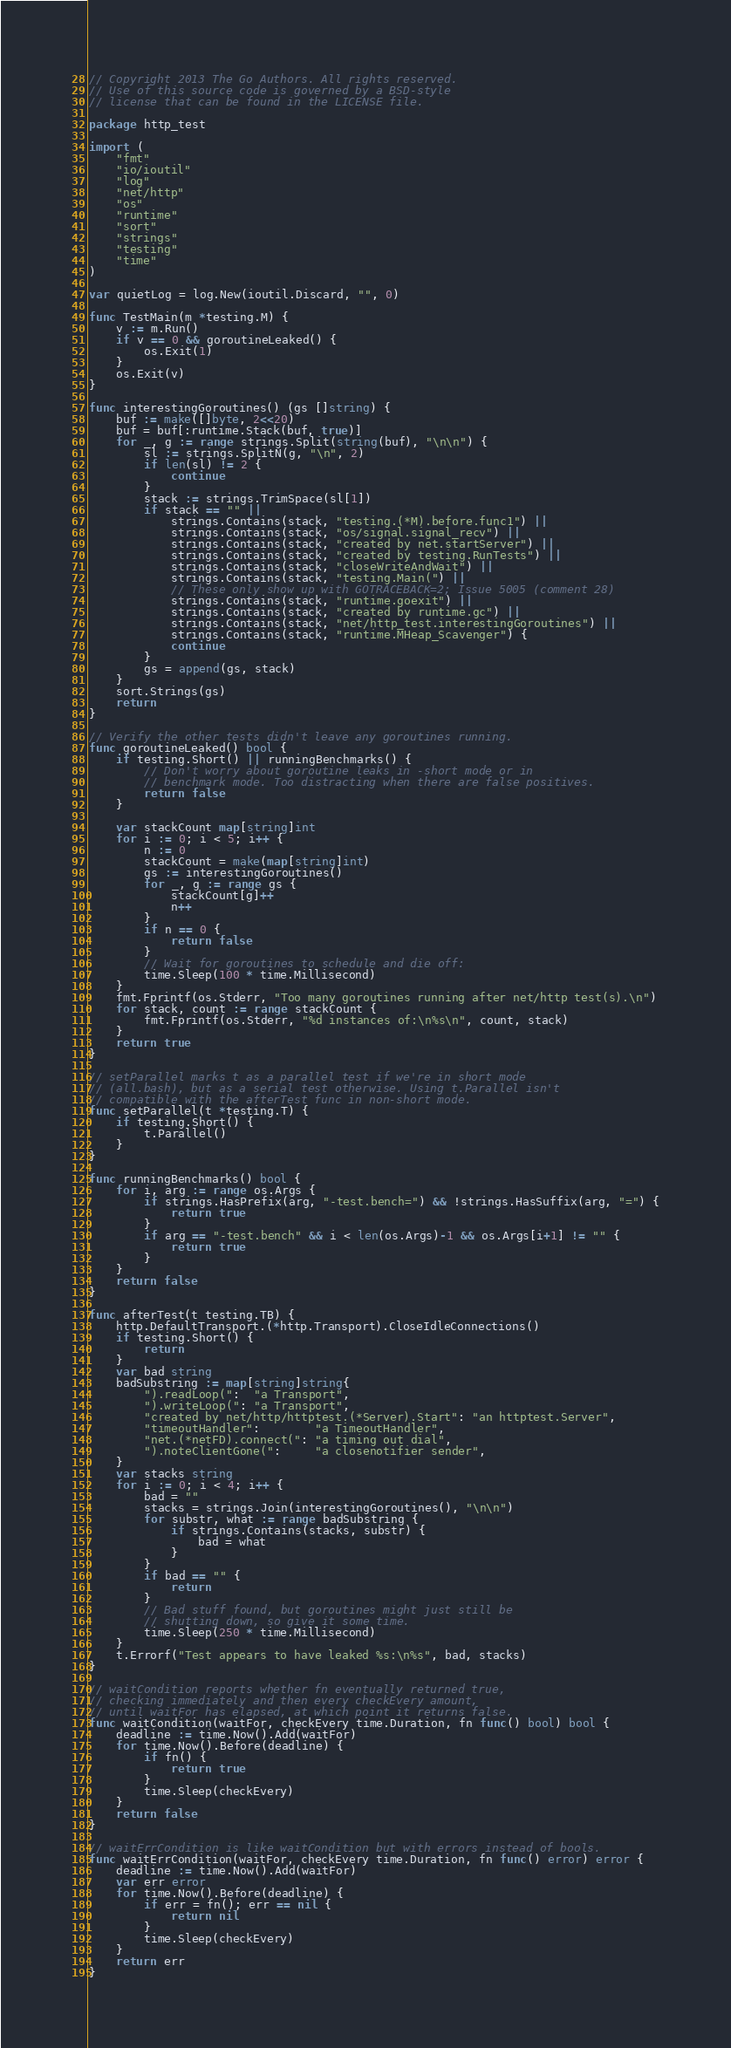Convert code to text. <code><loc_0><loc_0><loc_500><loc_500><_Go_>// Copyright 2013 The Go Authors. All rights reserved.
// Use of this source code is governed by a BSD-style
// license that can be found in the LICENSE file.

package http_test

import (
	"fmt"
	"io/ioutil"
	"log"
	"net/http"
	"os"
	"runtime"
	"sort"
	"strings"
	"testing"
	"time"
)

var quietLog = log.New(ioutil.Discard, "", 0)

func TestMain(m *testing.M) {
	v := m.Run()
	if v == 0 && goroutineLeaked() {
		os.Exit(1)
	}
	os.Exit(v)
}

func interestingGoroutines() (gs []string) {
	buf := make([]byte, 2<<20)
	buf = buf[:runtime.Stack(buf, true)]
	for _, g := range strings.Split(string(buf), "\n\n") {
		sl := strings.SplitN(g, "\n", 2)
		if len(sl) != 2 {
			continue
		}
		stack := strings.TrimSpace(sl[1])
		if stack == "" ||
			strings.Contains(stack, "testing.(*M).before.func1") ||
			strings.Contains(stack, "os/signal.signal_recv") ||
			strings.Contains(stack, "created by net.startServer") ||
			strings.Contains(stack, "created by testing.RunTests") ||
			strings.Contains(stack, "closeWriteAndWait") ||
			strings.Contains(stack, "testing.Main(") ||
			// These only show up with GOTRACEBACK=2; Issue 5005 (comment 28)
			strings.Contains(stack, "runtime.goexit") ||
			strings.Contains(stack, "created by runtime.gc") ||
			strings.Contains(stack, "net/http_test.interestingGoroutines") ||
			strings.Contains(stack, "runtime.MHeap_Scavenger") {
			continue
		}
		gs = append(gs, stack)
	}
	sort.Strings(gs)
	return
}

// Verify the other tests didn't leave any goroutines running.
func goroutineLeaked() bool {
	if testing.Short() || runningBenchmarks() {
		// Don't worry about goroutine leaks in -short mode or in
		// benchmark mode. Too distracting when there are false positives.
		return false
	}

	var stackCount map[string]int
	for i := 0; i < 5; i++ {
		n := 0
		stackCount = make(map[string]int)
		gs := interestingGoroutines()
		for _, g := range gs {
			stackCount[g]++
			n++
		}
		if n == 0 {
			return false
		}
		// Wait for goroutines to schedule and die off:
		time.Sleep(100 * time.Millisecond)
	}
	fmt.Fprintf(os.Stderr, "Too many goroutines running after net/http test(s).\n")
	for stack, count := range stackCount {
		fmt.Fprintf(os.Stderr, "%d instances of:\n%s\n", count, stack)
	}
	return true
}

// setParallel marks t as a parallel test if we're in short mode
// (all.bash), but as a serial test otherwise. Using t.Parallel isn't
// compatible with the afterTest func in non-short mode.
func setParallel(t *testing.T) {
	if testing.Short() {
		t.Parallel()
	}
}

func runningBenchmarks() bool {
	for i, arg := range os.Args {
		if strings.HasPrefix(arg, "-test.bench=") && !strings.HasSuffix(arg, "=") {
			return true
		}
		if arg == "-test.bench" && i < len(os.Args)-1 && os.Args[i+1] != "" {
			return true
		}
	}
	return false
}

func afterTest(t testing.TB) {
	http.DefaultTransport.(*http.Transport).CloseIdleConnections()
	if testing.Short() {
		return
	}
	var bad string
	badSubstring := map[string]string{
		").readLoop(":  "a Transport",
		").writeLoop(": "a Transport",
		"created by net/http/httptest.(*Server).Start": "an httptest.Server",
		"timeoutHandler":        "a TimeoutHandler",
		"net.(*netFD).connect(": "a timing out dial",
		").noteClientGone(":     "a closenotifier sender",
	}
	var stacks string
	for i := 0; i < 4; i++ {
		bad = ""
		stacks = strings.Join(interestingGoroutines(), "\n\n")
		for substr, what := range badSubstring {
			if strings.Contains(stacks, substr) {
				bad = what
			}
		}
		if bad == "" {
			return
		}
		// Bad stuff found, but goroutines might just still be
		// shutting down, so give it some time.
		time.Sleep(250 * time.Millisecond)
	}
	t.Errorf("Test appears to have leaked %s:\n%s", bad, stacks)
}

// waitCondition reports whether fn eventually returned true,
// checking immediately and then every checkEvery amount,
// until waitFor has elapsed, at which point it returns false.
func waitCondition(waitFor, checkEvery time.Duration, fn func() bool) bool {
	deadline := time.Now().Add(waitFor)
	for time.Now().Before(deadline) {
		if fn() {
			return true
		}
		time.Sleep(checkEvery)
	}
	return false
}

// waitErrCondition is like waitCondition but with errors instead of bools.
func waitErrCondition(waitFor, checkEvery time.Duration, fn func() error) error {
	deadline := time.Now().Add(waitFor)
	var err error
	for time.Now().Before(deadline) {
		if err = fn(); err == nil {
			return nil
		}
		time.Sleep(checkEvery)
	}
	return err
}
</code> 